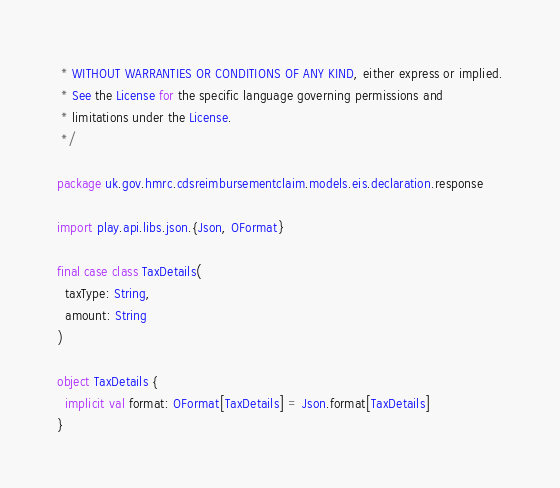<code> <loc_0><loc_0><loc_500><loc_500><_Scala_> * WITHOUT WARRANTIES OR CONDITIONS OF ANY KIND, either express or implied.
 * See the License for the specific language governing permissions and
 * limitations under the License.
 */

package uk.gov.hmrc.cdsreimbursementclaim.models.eis.declaration.response

import play.api.libs.json.{Json, OFormat}

final case class TaxDetails(
  taxType: String,
  amount: String
)

object TaxDetails {
  implicit val format: OFormat[TaxDetails] = Json.format[TaxDetails]
}
</code> 